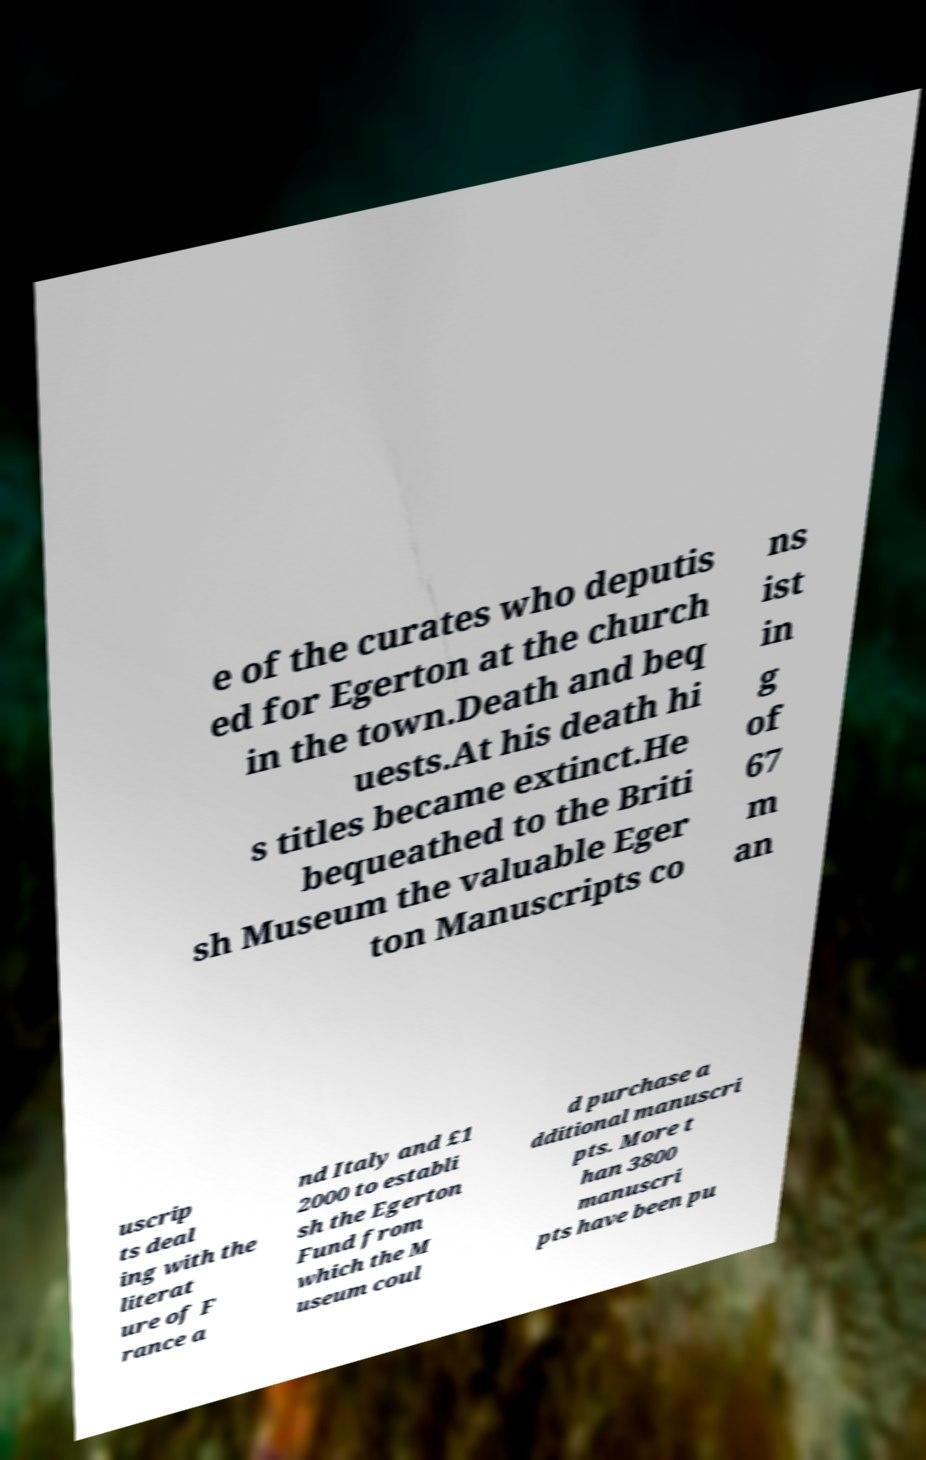I need the written content from this picture converted into text. Can you do that? e of the curates who deputis ed for Egerton at the church in the town.Death and beq uests.At his death hi s titles became extinct.He bequeathed to the Briti sh Museum the valuable Eger ton Manuscripts co ns ist in g of 67 m an uscrip ts deal ing with the literat ure of F rance a nd Italy and £1 2000 to establi sh the Egerton Fund from which the M useum coul d purchase a dditional manuscri pts. More t han 3800 manuscri pts have been pu 